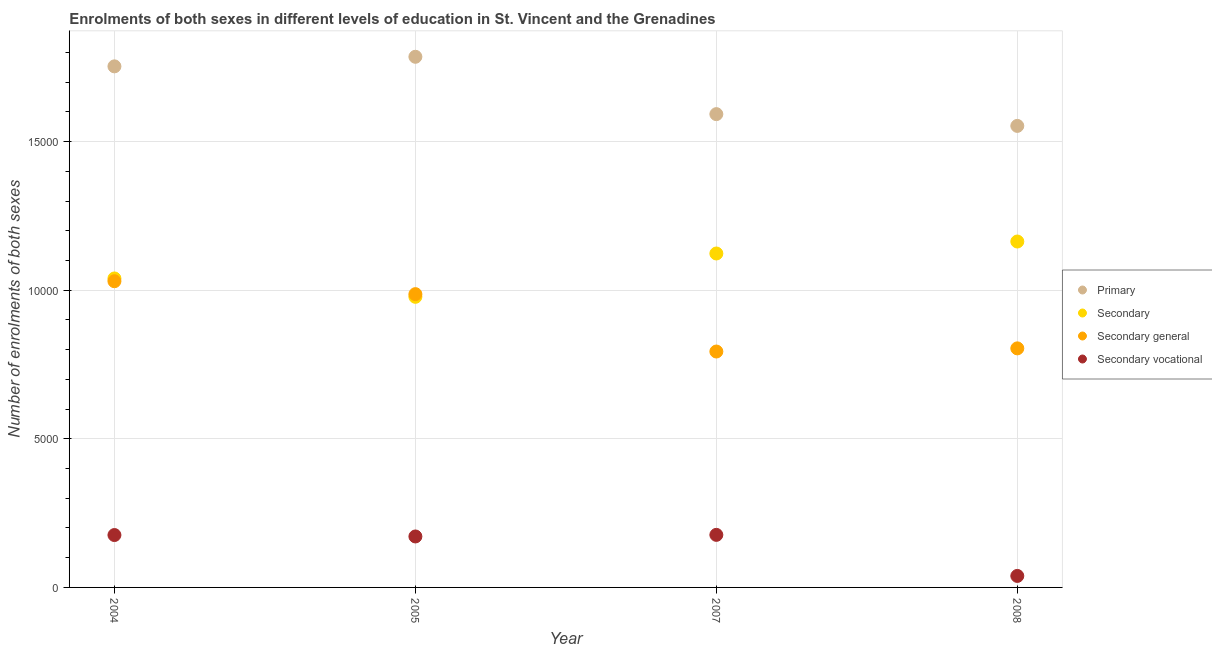Is the number of dotlines equal to the number of legend labels?
Provide a succinct answer. Yes. What is the number of enrolments in secondary vocational education in 2005?
Your response must be concise. 1715. Across all years, what is the maximum number of enrolments in secondary vocational education?
Ensure brevity in your answer.  1769. Across all years, what is the minimum number of enrolments in secondary education?
Provide a short and direct response. 9780. In which year was the number of enrolments in secondary vocational education maximum?
Your response must be concise. 2007. What is the total number of enrolments in secondary vocational education in the graph?
Make the answer very short. 5634. What is the difference between the number of enrolments in primary education in 2004 and that in 2005?
Your answer should be very brief. -322. What is the difference between the number of enrolments in secondary general education in 2008 and the number of enrolments in secondary vocational education in 2005?
Keep it short and to the point. 6330. What is the average number of enrolments in primary education per year?
Your answer should be compact. 1.67e+04. In the year 2005, what is the difference between the number of enrolments in primary education and number of enrolments in secondary general education?
Your response must be concise. 7988. In how many years, is the number of enrolments in primary education greater than 10000?
Ensure brevity in your answer.  4. What is the ratio of the number of enrolments in primary education in 2005 to that in 2007?
Your answer should be compact. 1.12. Is the number of enrolments in secondary education in 2004 less than that in 2008?
Ensure brevity in your answer.  Yes. Is the difference between the number of enrolments in secondary vocational education in 2005 and 2007 greater than the difference between the number of enrolments in secondary general education in 2005 and 2007?
Give a very brief answer. No. What is the difference between the highest and the lowest number of enrolments in secondary vocational education?
Your answer should be very brief. 1382. In how many years, is the number of enrolments in secondary vocational education greater than the average number of enrolments in secondary vocational education taken over all years?
Your response must be concise. 3. Is it the case that in every year, the sum of the number of enrolments in primary education and number of enrolments in secondary education is greater than the number of enrolments in secondary general education?
Provide a succinct answer. Yes. Does the number of enrolments in secondary vocational education monotonically increase over the years?
Your answer should be compact. No. Is the number of enrolments in secondary education strictly greater than the number of enrolments in primary education over the years?
Provide a succinct answer. No. How many dotlines are there?
Make the answer very short. 4. How many years are there in the graph?
Make the answer very short. 4. Are the values on the major ticks of Y-axis written in scientific E-notation?
Your answer should be compact. No. Does the graph contain any zero values?
Your answer should be very brief. No. Where does the legend appear in the graph?
Your answer should be compact. Center right. How many legend labels are there?
Offer a terse response. 4. What is the title of the graph?
Offer a terse response. Enrolments of both sexes in different levels of education in St. Vincent and the Grenadines. Does "Environmental sustainability" appear as one of the legend labels in the graph?
Provide a succinct answer. No. What is the label or title of the Y-axis?
Make the answer very short. Number of enrolments of both sexes. What is the Number of enrolments of both sexes of Primary in 2004?
Ensure brevity in your answer.  1.75e+04. What is the Number of enrolments of both sexes of Secondary in 2004?
Your answer should be very brief. 1.04e+04. What is the Number of enrolments of both sexes in Secondary general in 2004?
Your answer should be compact. 1.03e+04. What is the Number of enrolments of both sexes of Secondary vocational in 2004?
Give a very brief answer. 1763. What is the Number of enrolments of both sexes in Primary in 2005?
Your answer should be compact. 1.79e+04. What is the Number of enrolments of both sexes of Secondary in 2005?
Provide a succinct answer. 9780. What is the Number of enrolments of both sexes in Secondary general in 2005?
Offer a very short reply. 9870. What is the Number of enrolments of both sexes of Secondary vocational in 2005?
Your response must be concise. 1715. What is the Number of enrolments of both sexes of Primary in 2007?
Give a very brief answer. 1.59e+04. What is the Number of enrolments of both sexes of Secondary in 2007?
Your answer should be compact. 1.12e+04. What is the Number of enrolments of both sexes of Secondary general in 2007?
Keep it short and to the point. 7939. What is the Number of enrolments of both sexes in Secondary vocational in 2007?
Ensure brevity in your answer.  1769. What is the Number of enrolments of both sexes in Primary in 2008?
Ensure brevity in your answer.  1.55e+04. What is the Number of enrolments of both sexes of Secondary in 2008?
Offer a terse response. 1.16e+04. What is the Number of enrolments of both sexes of Secondary general in 2008?
Provide a short and direct response. 8045. What is the Number of enrolments of both sexes in Secondary vocational in 2008?
Make the answer very short. 387. Across all years, what is the maximum Number of enrolments of both sexes of Primary?
Your response must be concise. 1.79e+04. Across all years, what is the maximum Number of enrolments of both sexes in Secondary?
Give a very brief answer. 1.16e+04. Across all years, what is the maximum Number of enrolments of both sexes in Secondary general?
Offer a terse response. 1.03e+04. Across all years, what is the maximum Number of enrolments of both sexes in Secondary vocational?
Your answer should be very brief. 1769. Across all years, what is the minimum Number of enrolments of both sexes in Primary?
Offer a very short reply. 1.55e+04. Across all years, what is the minimum Number of enrolments of both sexes of Secondary?
Offer a very short reply. 9780. Across all years, what is the minimum Number of enrolments of both sexes of Secondary general?
Your answer should be compact. 7939. Across all years, what is the minimum Number of enrolments of both sexes in Secondary vocational?
Your answer should be compact. 387. What is the total Number of enrolments of both sexes in Primary in the graph?
Your answer should be compact. 6.69e+04. What is the total Number of enrolments of both sexes in Secondary in the graph?
Provide a succinct answer. 4.31e+04. What is the total Number of enrolments of both sexes in Secondary general in the graph?
Offer a very short reply. 3.62e+04. What is the total Number of enrolments of both sexes in Secondary vocational in the graph?
Make the answer very short. 5634. What is the difference between the Number of enrolments of both sexes of Primary in 2004 and that in 2005?
Keep it short and to the point. -322. What is the difference between the Number of enrolments of both sexes in Secondary in 2004 and that in 2005?
Give a very brief answer. 618. What is the difference between the Number of enrolments of both sexes in Secondary general in 2004 and that in 2005?
Provide a succinct answer. 435. What is the difference between the Number of enrolments of both sexes in Secondary vocational in 2004 and that in 2005?
Provide a succinct answer. 48. What is the difference between the Number of enrolments of both sexes of Primary in 2004 and that in 2007?
Ensure brevity in your answer.  1608. What is the difference between the Number of enrolments of both sexes in Secondary in 2004 and that in 2007?
Provide a short and direct response. -840. What is the difference between the Number of enrolments of both sexes of Secondary general in 2004 and that in 2007?
Your response must be concise. 2366. What is the difference between the Number of enrolments of both sexes in Secondary vocational in 2004 and that in 2007?
Provide a succinct answer. -6. What is the difference between the Number of enrolments of both sexes in Primary in 2004 and that in 2008?
Offer a very short reply. 2004. What is the difference between the Number of enrolments of both sexes in Secondary in 2004 and that in 2008?
Keep it short and to the point. -1243. What is the difference between the Number of enrolments of both sexes in Secondary general in 2004 and that in 2008?
Offer a very short reply. 2260. What is the difference between the Number of enrolments of both sexes in Secondary vocational in 2004 and that in 2008?
Offer a very short reply. 1376. What is the difference between the Number of enrolments of both sexes of Primary in 2005 and that in 2007?
Provide a succinct answer. 1930. What is the difference between the Number of enrolments of both sexes in Secondary in 2005 and that in 2007?
Offer a very short reply. -1458. What is the difference between the Number of enrolments of both sexes of Secondary general in 2005 and that in 2007?
Provide a short and direct response. 1931. What is the difference between the Number of enrolments of both sexes in Secondary vocational in 2005 and that in 2007?
Offer a terse response. -54. What is the difference between the Number of enrolments of both sexes in Primary in 2005 and that in 2008?
Make the answer very short. 2326. What is the difference between the Number of enrolments of both sexes in Secondary in 2005 and that in 2008?
Provide a succinct answer. -1861. What is the difference between the Number of enrolments of both sexes in Secondary general in 2005 and that in 2008?
Your answer should be compact. 1825. What is the difference between the Number of enrolments of both sexes of Secondary vocational in 2005 and that in 2008?
Give a very brief answer. 1328. What is the difference between the Number of enrolments of both sexes of Primary in 2007 and that in 2008?
Your response must be concise. 396. What is the difference between the Number of enrolments of both sexes of Secondary in 2007 and that in 2008?
Make the answer very short. -403. What is the difference between the Number of enrolments of both sexes in Secondary general in 2007 and that in 2008?
Your answer should be very brief. -106. What is the difference between the Number of enrolments of both sexes in Secondary vocational in 2007 and that in 2008?
Offer a very short reply. 1382. What is the difference between the Number of enrolments of both sexes of Primary in 2004 and the Number of enrolments of both sexes of Secondary in 2005?
Keep it short and to the point. 7756. What is the difference between the Number of enrolments of both sexes in Primary in 2004 and the Number of enrolments of both sexes in Secondary general in 2005?
Give a very brief answer. 7666. What is the difference between the Number of enrolments of both sexes of Primary in 2004 and the Number of enrolments of both sexes of Secondary vocational in 2005?
Your answer should be very brief. 1.58e+04. What is the difference between the Number of enrolments of both sexes in Secondary in 2004 and the Number of enrolments of both sexes in Secondary general in 2005?
Provide a succinct answer. 528. What is the difference between the Number of enrolments of both sexes in Secondary in 2004 and the Number of enrolments of both sexes in Secondary vocational in 2005?
Your answer should be compact. 8683. What is the difference between the Number of enrolments of both sexes of Secondary general in 2004 and the Number of enrolments of both sexes of Secondary vocational in 2005?
Your response must be concise. 8590. What is the difference between the Number of enrolments of both sexes of Primary in 2004 and the Number of enrolments of both sexes of Secondary in 2007?
Your answer should be compact. 6298. What is the difference between the Number of enrolments of both sexes in Primary in 2004 and the Number of enrolments of both sexes in Secondary general in 2007?
Your response must be concise. 9597. What is the difference between the Number of enrolments of both sexes in Primary in 2004 and the Number of enrolments of both sexes in Secondary vocational in 2007?
Provide a succinct answer. 1.58e+04. What is the difference between the Number of enrolments of both sexes of Secondary in 2004 and the Number of enrolments of both sexes of Secondary general in 2007?
Make the answer very short. 2459. What is the difference between the Number of enrolments of both sexes of Secondary in 2004 and the Number of enrolments of both sexes of Secondary vocational in 2007?
Give a very brief answer. 8629. What is the difference between the Number of enrolments of both sexes of Secondary general in 2004 and the Number of enrolments of both sexes of Secondary vocational in 2007?
Give a very brief answer. 8536. What is the difference between the Number of enrolments of both sexes of Primary in 2004 and the Number of enrolments of both sexes of Secondary in 2008?
Offer a terse response. 5895. What is the difference between the Number of enrolments of both sexes in Primary in 2004 and the Number of enrolments of both sexes in Secondary general in 2008?
Your answer should be very brief. 9491. What is the difference between the Number of enrolments of both sexes of Primary in 2004 and the Number of enrolments of both sexes of Secondary vocational in 2008?
Ensure brevity in your answer.  1.71e+04. What is the difference between the Number of enrolments of both sexes of Secondary in 2004 and the Number of enrolments of both sexes of Secondary general in 2008?
Your response must be concise. 2353. What is the difference between the Number of enrolments of both sexes in Secondary in 2004 and the Number of enrolments of both sexes in Secondary vocational in 2008?
Offer a terse response. 1.00e+04. What is the difference between the Number of enrolments of both sexes in Secondary general in 2004 and the Number of enrolments of both sexes in Secondary vocational in 2008?
Give a very brief answer. 9918. What is the difference between the Number of enrolments of both sexes of Primary in 2005 and the Number of enrolments of both sexes of Secondary in 2007?
Your response must be concise. 6620. What is the difference between the Number of enrolments of both sexes in Primary in 2005 and the Number of enrolments of both sexes in Secondary general in 2007?
Make the answer very short. 9919. What is the difference between the Number of enrolments of both sexes in Primary in 2005 and the Number of enrolments of both sexes in Secondary vocational in 2007?
Offer a terse response. 1.61e+04. What is the difference between the Number of enrolments of both sexes in Secondary in 2005 and the Number of enrolments of both sexes in Secondary general in 2007?
Offer a very short reply. 1841. What is the difference between the Number of enrolments of both sexes of Secondary in 2005 and the Number of enrolments of both sexes of Secondary vocational in 2007?
Provide a short and direct response. 8011. What is the difference between the Number of enrolments of both sexes in Secondary general in 2005 and the Number of enrolments of both sexes in Secondary vocational in 2007?
Ensure brevity in your answer.  8101. What is the difference between the Number of enrolments of both sexes of Primary in 2005 and the Number of enrolments of both sexes of Secondary in 2008?
Keep it short and to the point. 6217. What is the difference between the Number of enrolments of both sexes of Primary in 2005 and the Number of enrolments of both sexes of Secondary general in 2008?
Provide a succinct answer. 9813. What is the difference between the Number of enrolments of both sexes in Primary in 2005 and the Number of enrolments of both sexes in Secondary vocational in 2008?
Offer a very short reply. 1.75e+04. What is the difference between the Number of enrolments of both sexes in Secondary in 2005 and the Number of enrolments of both sexes in Secondary general in 2008?
Your response must be concise. 1735. What is the difference between the Number of enrolments of both sexes of Secondary in 2005 and the Number of enrolments of both sexes of Secondary vocational in 2008?
Your answer should be very brief. 9393. What is the difference between the Number of enrolments of both sexes in Secondary general in 2005 and the Number of enrolments of both sexes in Secondary vocational in 2008?
Ensure brevity in your answer.  9483. What is the difference between the Number of enrolments of both sexes of Primary in 2007 and the Number of enrolments of both sexes of Secondary in 2008?
Offer a very short reply. 4287. What is the difference between the Number of enrolments of both sexes in Primary in 2007 and the Number of enrolments of both sexes in Secondary general in 2008?
Give a very brief answer. 7883. What is the difference between the Number of enrolments of both sexes in Primary in 2007 and the Number of enrolments of both sexes in Secondary vocational in 2008?
Your response must be concise. 1.55e+04. What is the difference between the Number of enrolments of both sexes of Secondary in 2007 and the Number of enrolments of both sexes of Secondary general in 2008?
Keep it short and to the point. 3193. What is the difference between the Number of enrolments of both sexes of Secondary in 2007 and the Number of enrolments of both sexes of Secondary vocational in 2008?
Ensure brevity in your answer.  1.09e+04. What is the difference between the Number of enrolments of both sexes in Secondary general in 2007 and the Number of enrolments of both sexes in Secondary vocational in 2008?
Your response must be concise. 7552. What is the average Number of enrolments of both sexes in Primary per year?
Give a very brief answer. 1.67e+04. What is the average Number of enrolments of both sexes of Secondary per year?
Your response must be concise. 1.08e+04. What is the average Number of enrolments of both sexes in Secondary general per year?
Offer a terse response. 9039.75. What is the average Number of enrolments of both sexes of Secondary vocational per year?
Your answer should be compact. 1408.5. In the year 2004, what is the difference between the Number of enrolments of both sexes in Primary and Number of enrolments of both sexes in Secondary?
Keep it short and to the point. 7138. In the year 2004, what is the difference between the Number of enrolments of both sexes in Primary and Number of enrolments of both sexes in Secondary general?
Your answer should be compact. 7231. In the year 2004, what is the difference between the Number of enrolments of both sexes in Primary and Number of enrolments of both sexes in Secondary vocational?
Your response must be concise. 1.58e+04. In the year 2004, what is the difference between the Number of enrolments of both sexes in Secondary and Number of enrolments of both sexes in Secondary general?
Keep it short and to the point. 93. In the year 2004, what is the difference between the Number of enrolments of both sexes in Secondary and Number of enrolments of both sexes in Secondary vocational?
Give a very brief answer. 8635. In the year 2004, what is the difference between the Number of enrolments of both sexes in Secondary general and Number of enrolments of both sexes in Secondary vocational?
Offer a terse response. 8542. In the year 2005, what is the difference between the Number of enrolments of both sexes in Primary and Number of enrolments of both sexes in Secondary?
Your answer should be very brief. 8078. In the year 2005, what is the difference between the Number of enrolments of both sexes of Primary and Number of enrolments of both sexes of Secondary general?
Your answer should be compact. 7988. In the year 2005, what is the difference between the Number of enrolments of both sexes in Primary and Number of enrolments of both sexes in Secondary vocational?
Give a very brief answer. 1.61e+04. In the year 2005, what is the difference between the Number of enrolments of both sexes of Secondary and Number of enrolments of both sexes of Secondary general?
Offer a terse response. -90. In the year 2005, what is the difference between the Number of enrolments of both sexes in Secondary and Number of enrolments of both sexes in Secondary vocational?
Offer a terse response. 8065. In the year 2005, what is the difference between the Number of enrolments of both sexes in Secondary general and Number of enrolments of both sexes in Secondary vocational?
Offer a very short reply. 8155. In the year 2007, what is the difference between the Number of enrolments of both sexes of Primary and Number of enrolments of both sexes of Secondary?
Your answer should be compact. 4690. In the year 2007, what is the difference between the Number of enrolments of both sexes of Primary and Number of enrolments of both sexes of Secondary general?
Your response must be concise. 7989. In the year 2007, what is the difference between the Number of enrolments of both sexes of Primary and Number of enrolments of both sexes of Secondary vocational?
Offer a very short reply. 1.42e+04. In the year 2007, what is the difference between the Number of enrolments of both sexes in Secondary and Number of enrolments of both sexes in Secondary general?
Offer a terse response. 3299. In the year 2007, what is the difference between the Number of enrolments of both sexes in Secondary and Number of enrolments of both sexes in Secondary vocational?
Ensure brevity in your answer.  9469. In the year 2007, what is the difference between the Number of enrolments of both sexes of Secondary general and Number of enrolments of both sexes of Secondary vocational?
Provide a short and direct response. 6170. In the year 2008, what is the difference between the Number of enrolments of both sexes in Primary and Number of enrolments of both sexes in Secondary?
Provide a short and direct response. 3891. In the year 2008, what is the difference between the Number of enrolments of both sexes of Primary and Number of enrolments of both sexes of Secondary general?
Your answer should be very brief. 7487. In the year 2008, what is the difference between the Number of enrolments of both sexes of Primary and Number of enrolments of both sexes of Secondary vocational?
Offer a very short reply. 1.51e+04. In the year 2008, what is the difference between the Number of enrolments of both sexes in Secondary and Number of enrolments of both sexes in Secondary general?
Offer a very short reply. 3596. In the year 2008, what is the difference between the Number of enrolments of both sexes of Secondary and Number of enrolments of both sexes of Secondary vocational?
Your response must be concise. 1.13e+04. In the year 2008, what is the difference between the Number of enrolments of both sexes in Secondary general and Number of enrolments of both sexes in Secondary vocational?
Offer a terse response. 7658. What is the ratio of the Number of enrolments of both sexes in Secondary in 2004 to that in 2005?
Provide a short and direct response. 1.06. What is the ratio of the Number of enrolments of both sexes in Secondary general in 2004 to that in 2005?
Offer a very short reply. 1.04. What is the ratio of the Number of enrolments of both sexes in Secondary vocational in 2004 to that in 2005?
Give a very brief answer. 1.03. What is the ratio of the Number of enrolments of both sexes in Primary in 2004 to that in 2007?
Ensure brevity in your answer.  1.1. What is the ratio of the Number of enrolments of both sexes in Secondary in 2004 to that in 2007?
Keep it short and to the point. 0.93. What is the ratio of the Number of enrolments of both sexes of Secondary general in 2004 to that in 2007?
Keep it short and to the point. 1.3. What is the ratio of the Number of enrolments of both sexes of Secondary vocational in 2004 to that in 2007?
Give a very brief answer. 1. What is the ratio of the Number of enrolments of both sexes in Primary in 2004 to that in 2008?
Your response must be concise. 1.13. What is the ratio of the Number of enrolments of both sexes of Secondary in 2004 to that in 2008?
Your answer should be very brief. 0.89. What is the ratio of the Number of enrolments of both sexes of Secondary general in 2004 to that in 2008?
Give a very brief answer. 1.28. What is the ratio of the Number of enrolments of both sexes of Secondary vocational in 2004 to that in 2008?
Keep it short and to the point. 4.56. What is the ratio of the Number of enrolments of both sexes of Primary in 2005 to that in 2007?
Give a very brief answer. 1.12. What is the ratio of the Number of enrolments of both sexes of Secondary in 2005 to that in 2007?
Keep it short and to the point. 0.87. What is the ratio of the Number of enrolments of both sexes of Secondary general in 2005 to that in 2007?
Provide a short and direct response. 1.24. What is the ratio of the Number of enrolments of both sexes in Secondary vocational in 2005 to that in 2007?
Keep it short and to the point. 0.97. What is the ratio of the Number of enrolments of both sexes of Primary in 2005 to that in 2008?
Give a very brief answer. 1.15. What is the ratio of the Number of enrolments of both sexes of Secondary in 2005 to that in 2008?
Your response must be concise. 0.84. What is the ratio of the Number of enrolments of both sexes of Secondary general in 2005 to that in 2008?
Offer a terse response. 1.23. What is the ratio of the Number of enrolments of both sexes of Secondary vocational in 2005 to that in 2008?
Your answer should be very brief. 4.43. What is the ratio of the Number of enrolments of both sexes of Primary in 2007 to that in 2008?
Keep it short and to the point. 1.03. What is the ratio of the Number of enrolments of both sexes in Secondary in 2007 to that in 2008?
Your answer should be very brief. 0.97. What is the ratio of the Number of enrolments of both sexes of Secondary vocational in 2007 to that in 2008?
Ensure brevity in your answer.  4.57. What is the difference between the highest and the second highest Number of enrolments of both sexes in Primary?
Your answer should be compact. 322. What is the difference between the highest and the second highest Number of enrolments of both sexes in Secondary?
Your response must be concise. 403. What is the difference between the highest and the second highest Number of enrolments of both sexes of Secondary general?
Offer a very short reply. 435. What is the difference between the highest and the second highest Number of enrolments of both sexes in Secondary vocational?
Your answer should be very brief. 6. What is the difference between the highest and the lowest Number of enrolments of both sexes in Primary?
Your response must be concise. 2326. What is the difference between the highest and the lowest Number of enrolments of both sexes of Secondary?
Provide a succinct answer. 1861. What is the difference between the highest and the lowest Number of enrolments of both sexes of Secondary general?
Provide a short and direct response. 2366. What is the difference between the highest and the lowest Number of enrolments of both sexes of Secondary vocational?
Keep it short and to the point. 1382. 